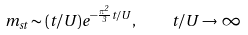<formula> <loc_0><loc_0><loc_500><loc_500>m _ { s t } \sim ( t / U ) e ^ { - \frac { \pi ^ { 2 } } { 3 } t / U } , \quad t / U \rightarrow \infty</formula> 